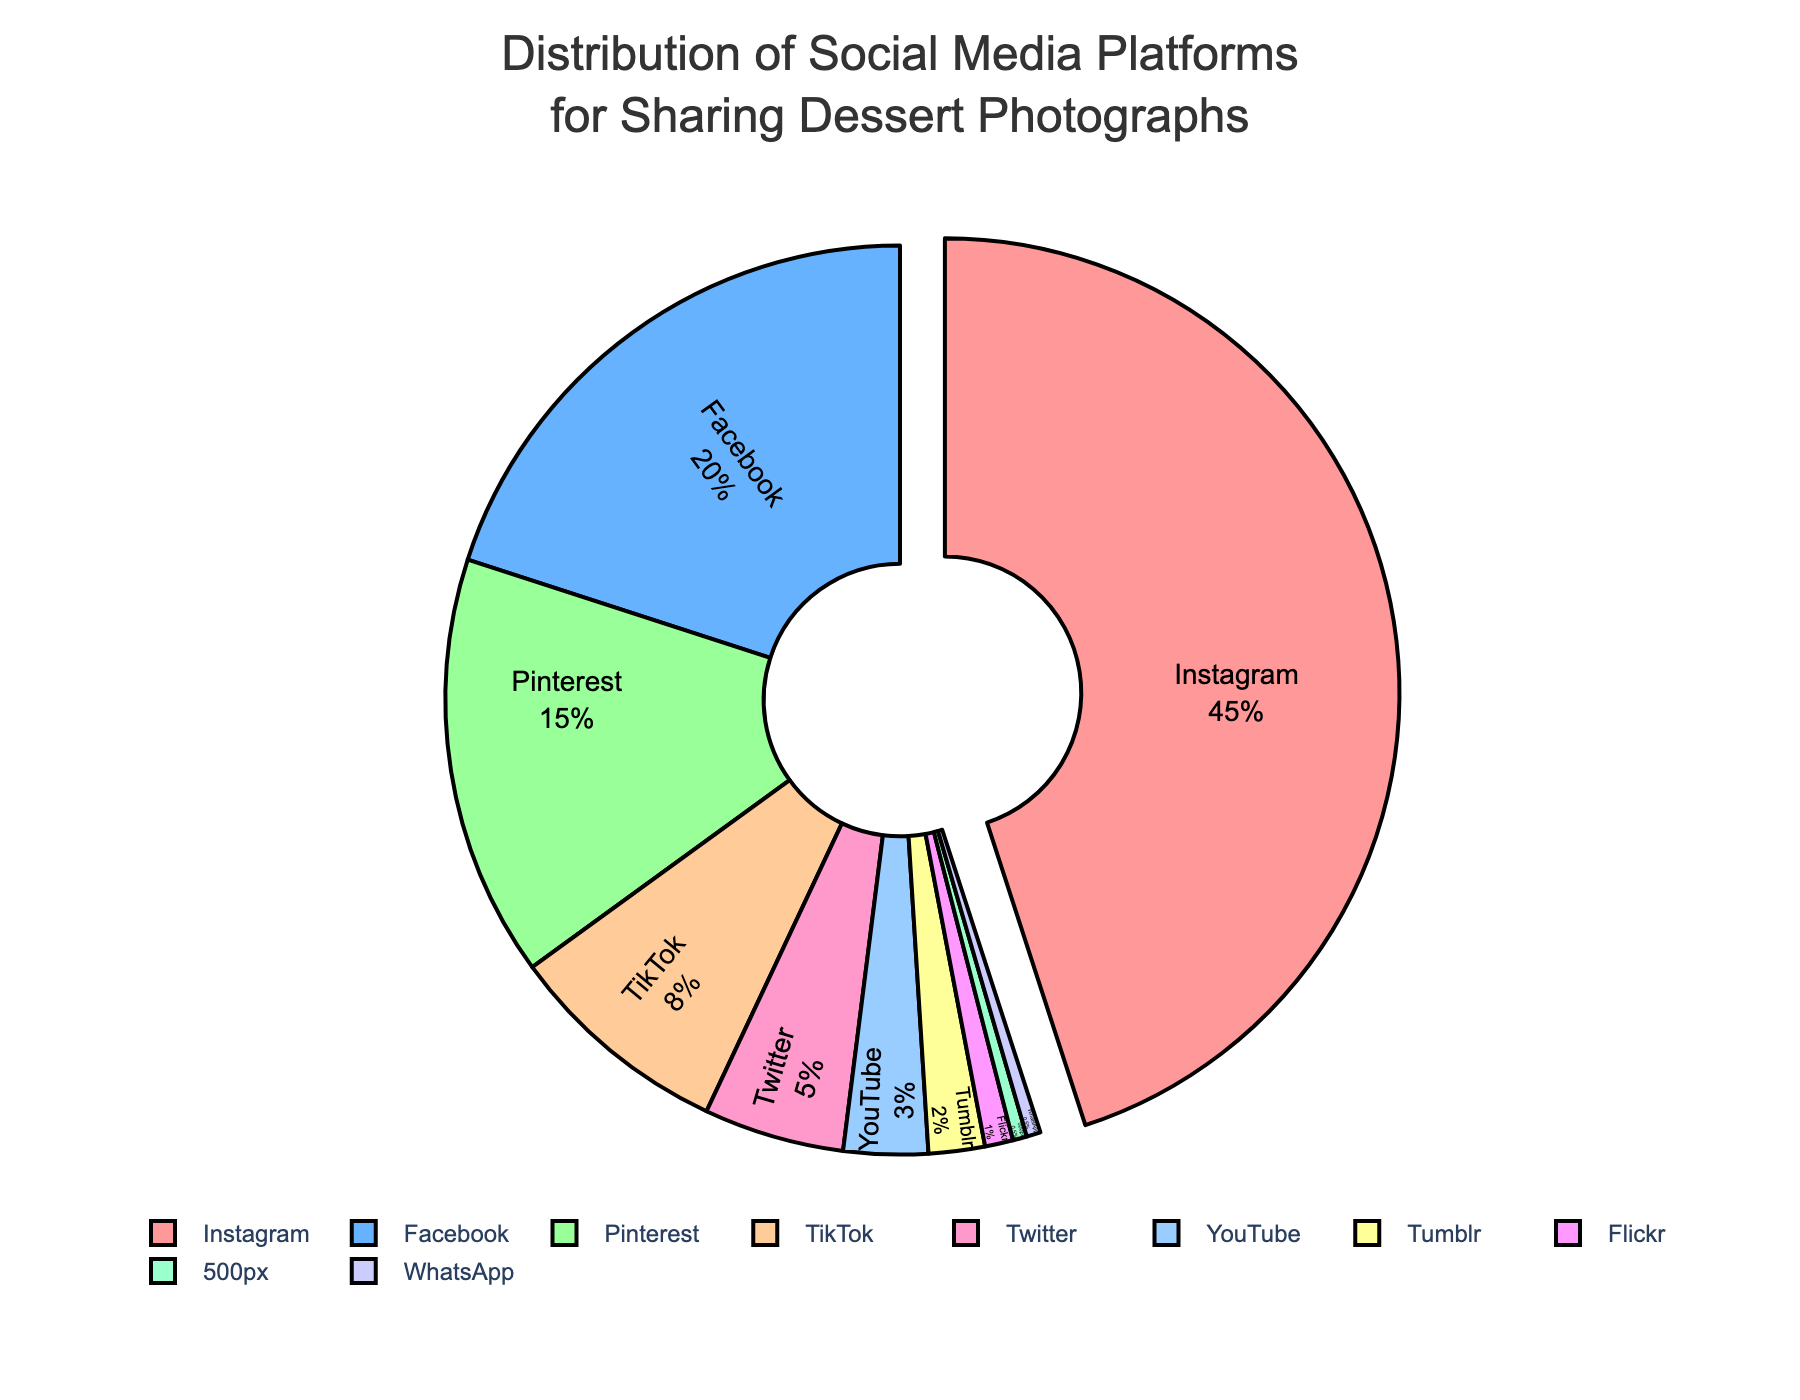Which social media platform is used the most for sharing dessert photographs? The platform with the largest percentage slice on the pie chart is used the most. The chart indicates that Instagram has the highest percentage.
Answer: Instagram Which two platforms together account for more than half of the distribution? Check the percentages of the platforms and sum them. Instagram has 45% and Facebook has 20%, summing to 65%, which is more than half.
Answer: Instagram and Facebook What is the combined percentage of platforms that share dessert photographs less than TikTok? Add the percentages of Twitter (5%), YouTube (3%), Tumblr (2%), Flickr (1%), and 500px and WhatsApp (0.5% each). The total is 12%.
Answer: 12% Is Facebook's percentage greater than the sum of Twitter and Pinterest? Compare Facebook’s percentage (20%) with the combined percentage of Twitter (5%) and Pinterest (15%), which is 20%. They are equal.
Answer: No What percentage of the distribution is accounted for by platforms that have less than 5% usage each? Add the percentages of Twitter (5%), YouTube (3%), Tumblr (2%), Flickr (1%), 500px (0.5%), and WhatsApp (0.5%). The total is 12%.
Answer: 12% Which social media platform has the smallest share in the distribution? The platform with the smallest percentage slice on the pie chart is the smallest. The chart shows both 500px and WhatsApp at 0.5%, but they are the same.
Answer: 500px and WhatsApp How much more is Instagram's percentage compared to Pinterest's? Subtract Pinterest’s percentage (15%) from Instagram’s (45%). The difference is 30%.
Answer: 30% What is the difference in the percentage of TikTok and Tumblr? Subtract Tumblr’s percentage (2%) from TikTok’s (8%). The difference is 6%.
Answer: 6% Which social media platform appears in blue on the chart? The pie chart uses colors, and the blue slice is Twitter.
Answer: Twitter What is the percentage difference between the platform with the highest and the one with the lowest share? Subtract the lowest percentage (500px and WhatsApp each at 0.5%) from the highest (Instagram at 45%). The difference is 44.5%.
Answer: 44.5% 